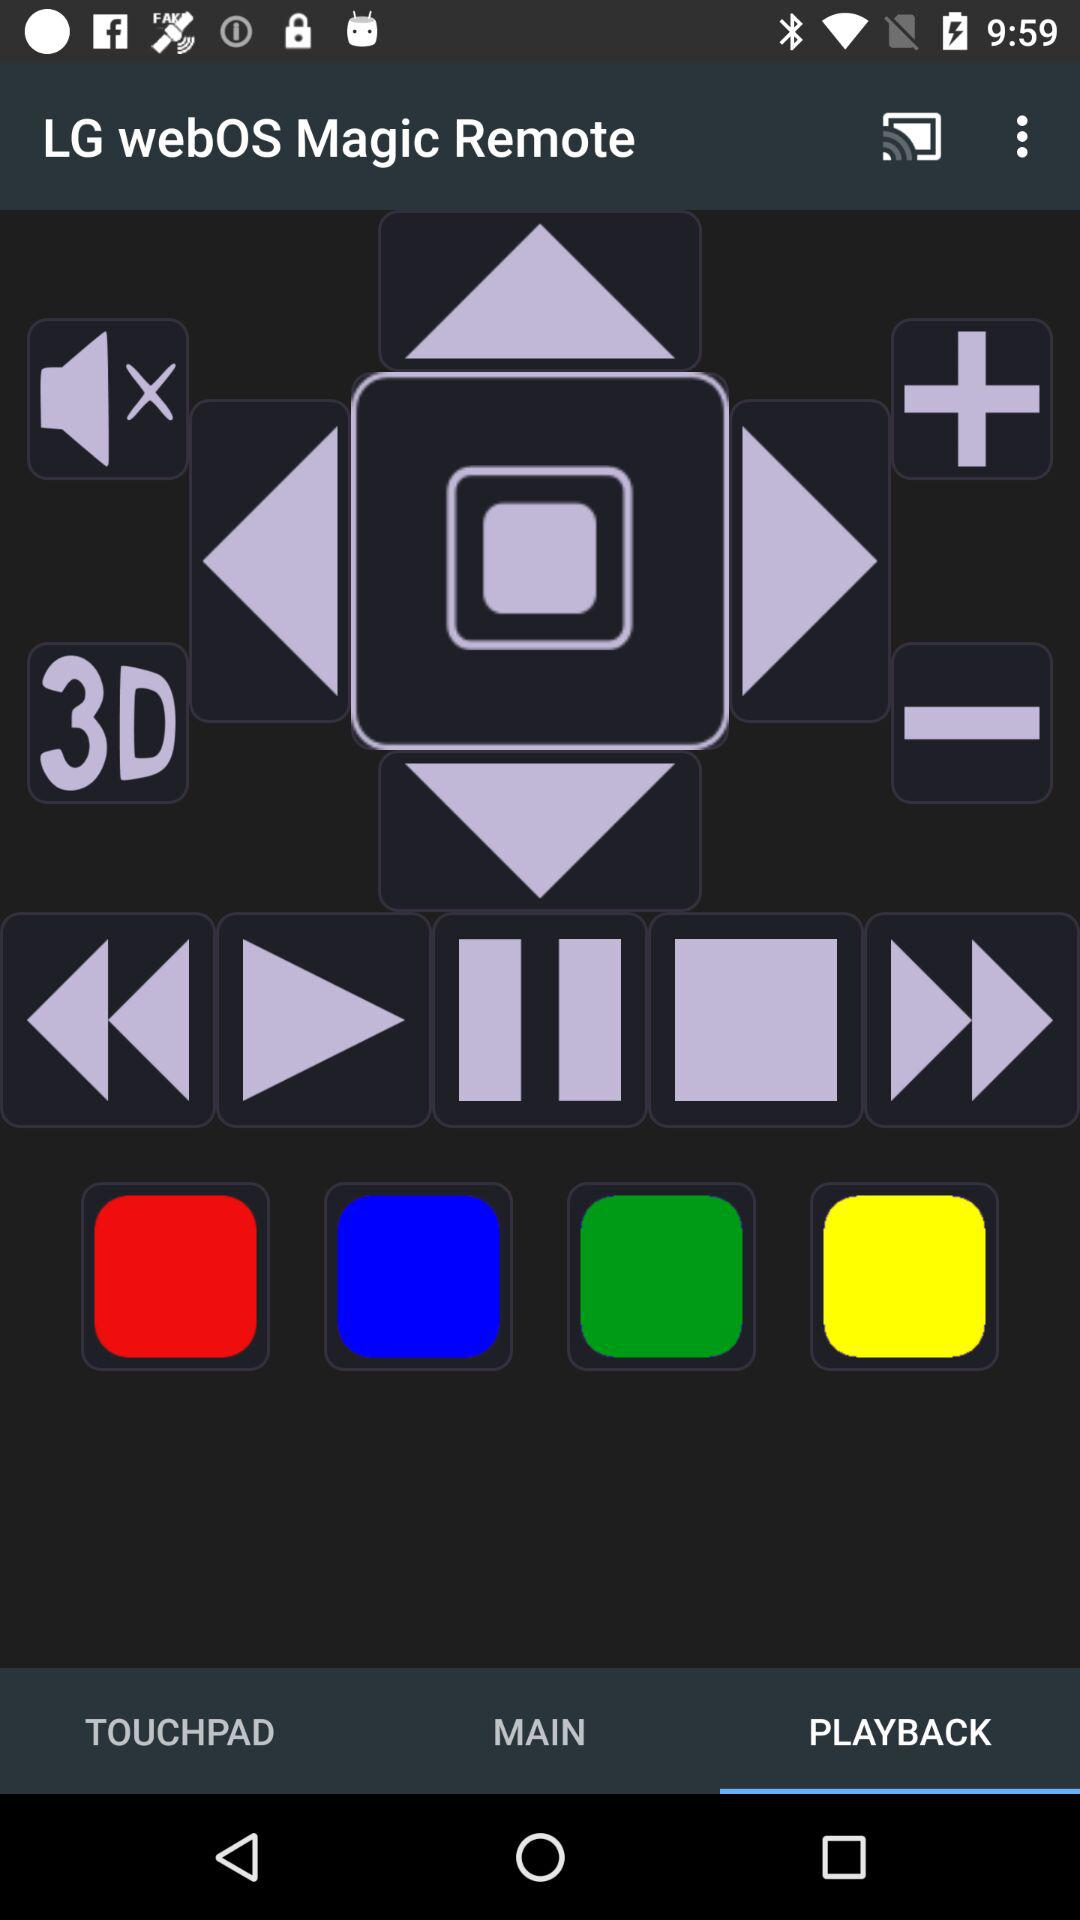What is the name of the application? The application name is "LG webOS Magic Remote". 